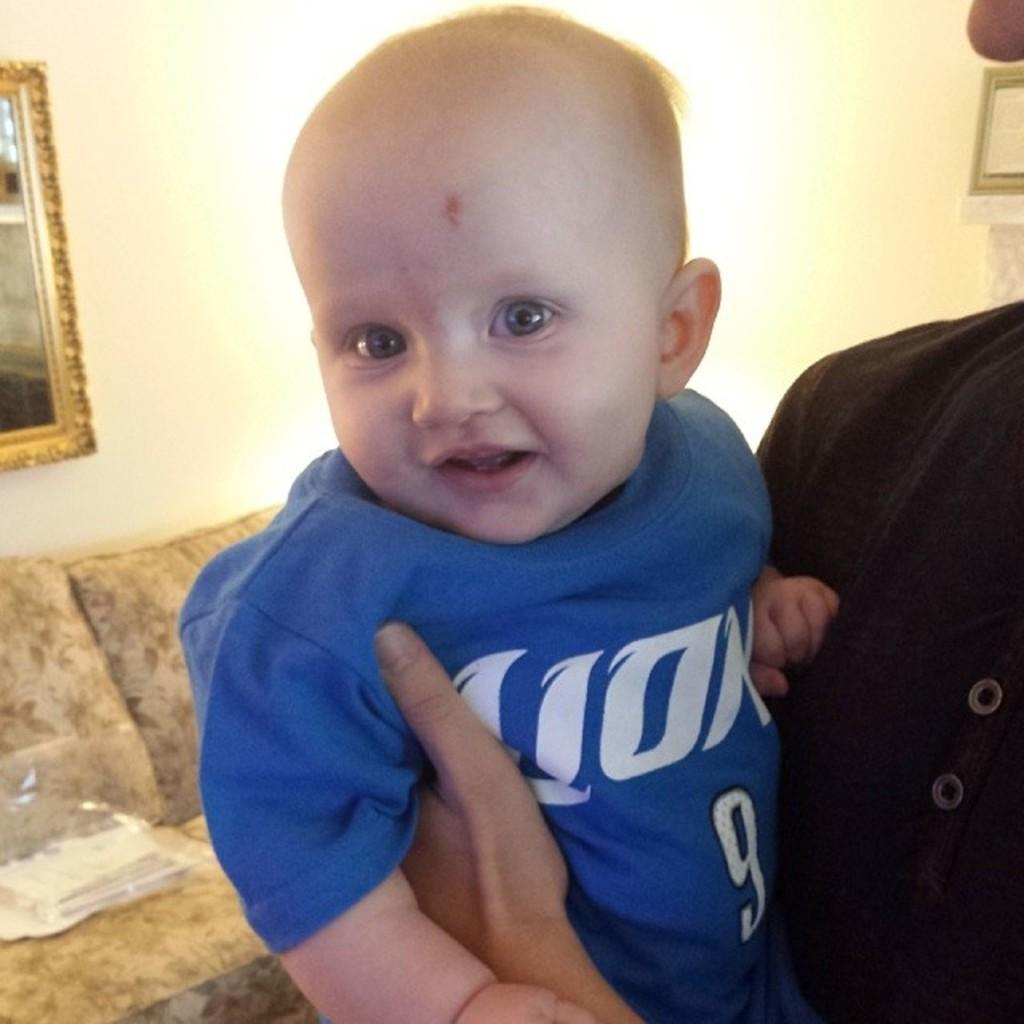Provide a one-sentence caption for the provided image. a baby wearing a 9 onsie has a mark on its head. 